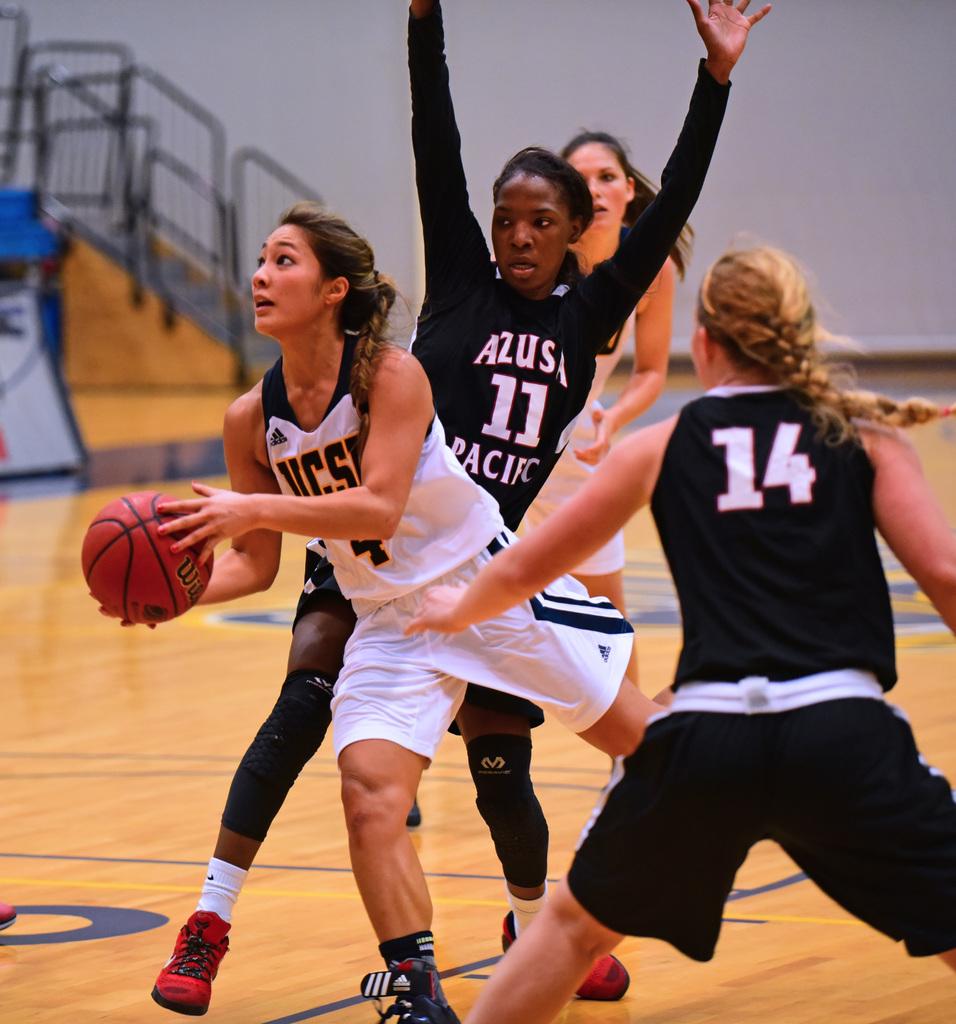What number is the blond woman?
Ensure brevity in your answer.  14. What sport are they playing?
Give a very brief answer. Answering does not require reading text in the image. 